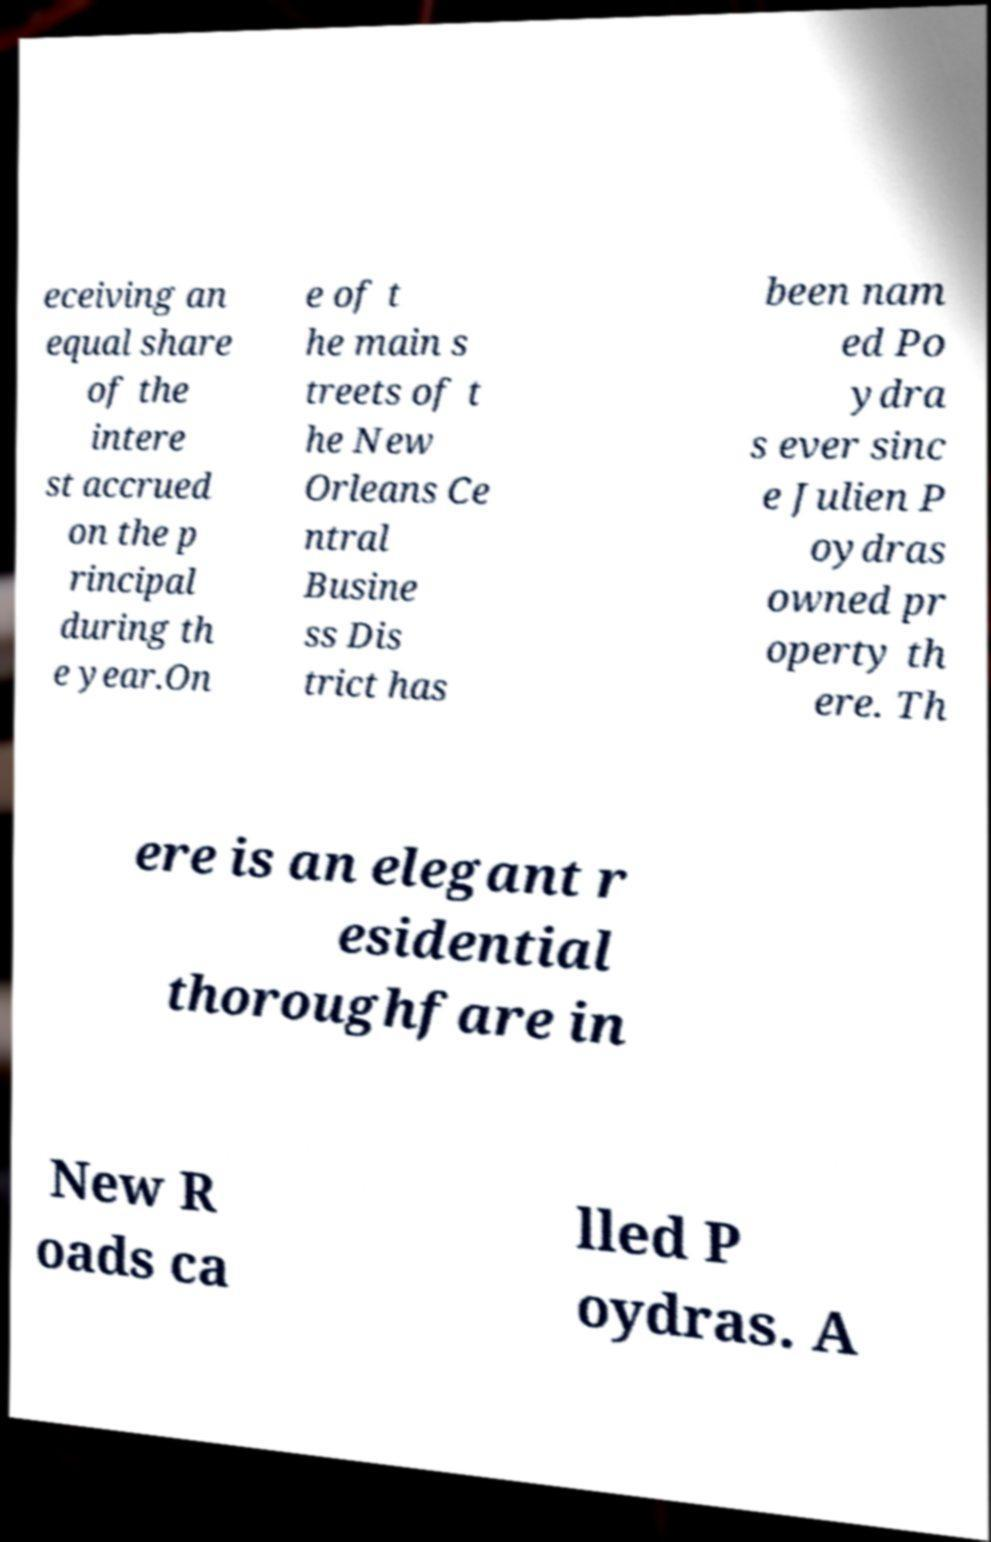What messages or text are displayed in this image? I need them in a readable, typed format. eceiving an equal share of the intere st accrued on the p rincipal during th e year.On e of t he main s treets of t he New Orleans Ce ntral Busine ss Dis trict has been nam ed Po ydra s ever sinc e Julien P oydras owned pr operty th ere. Th ere is an elegant r esidential thoroughfare in New R oads ca lled P oydras. A 